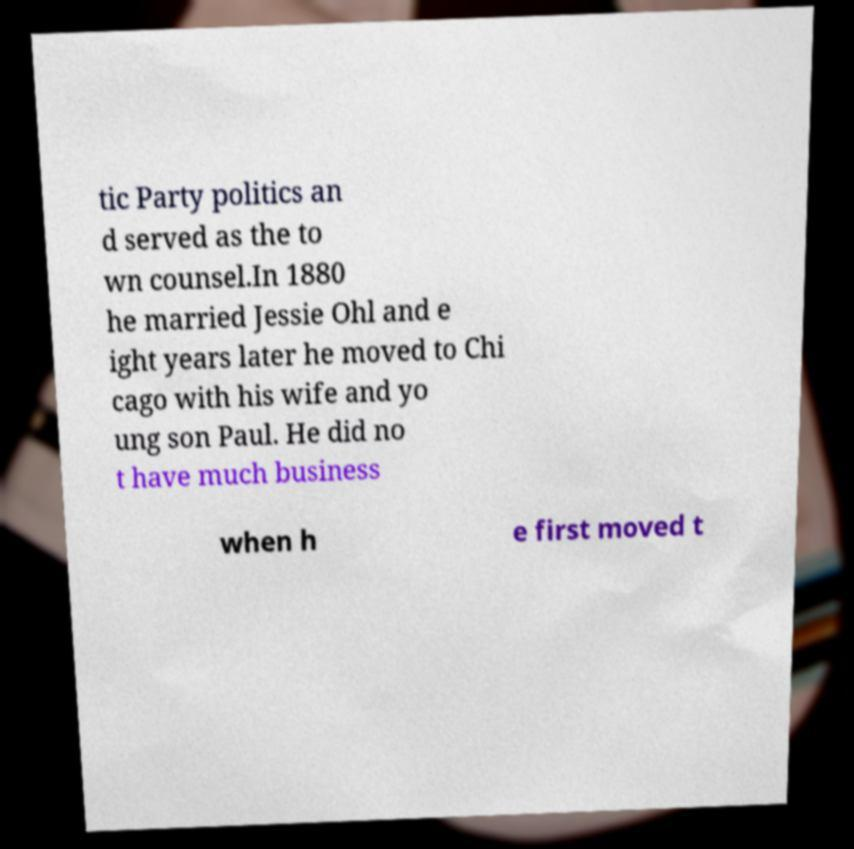Please identify and transcribe the text found in this image. tic Party politics an d served as the to wn counsel.In 1880 he married Jessie Ohl and e ight years later he moved to Chi cago with his wife and yo ung son Paul. He did no t have much business when h e first moved t 